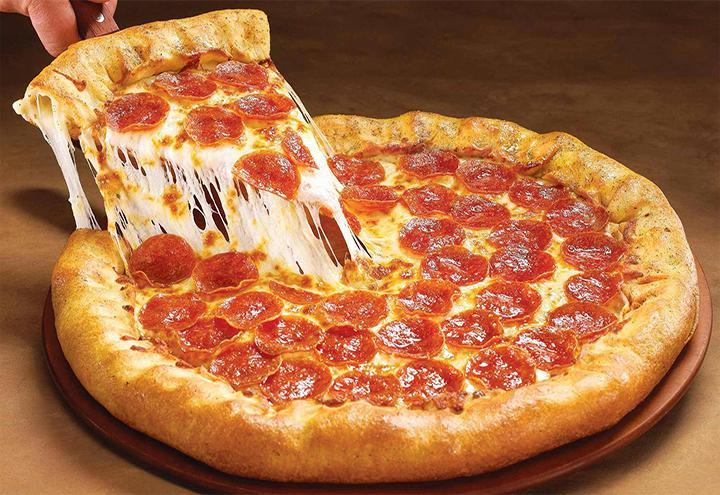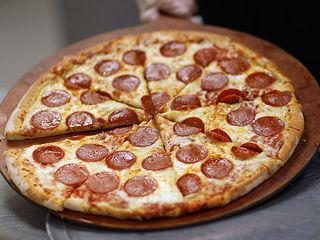The first image is the image on the left, the second image is the image on the right. For the images shown, is this caption "All pizzas pictured are whole without any pieces missing or removed." true? Answer yes or no. No. The first image is the image on the left, the second image is the image on the right. Considering the images on both sides, is "One image shows one sliced pepperoni pizza with all the slices still lying flat, and the other image shows a pepperoni pizza with a slice that is out of place and off the surface." valid? Answer yes or no. Yes. 